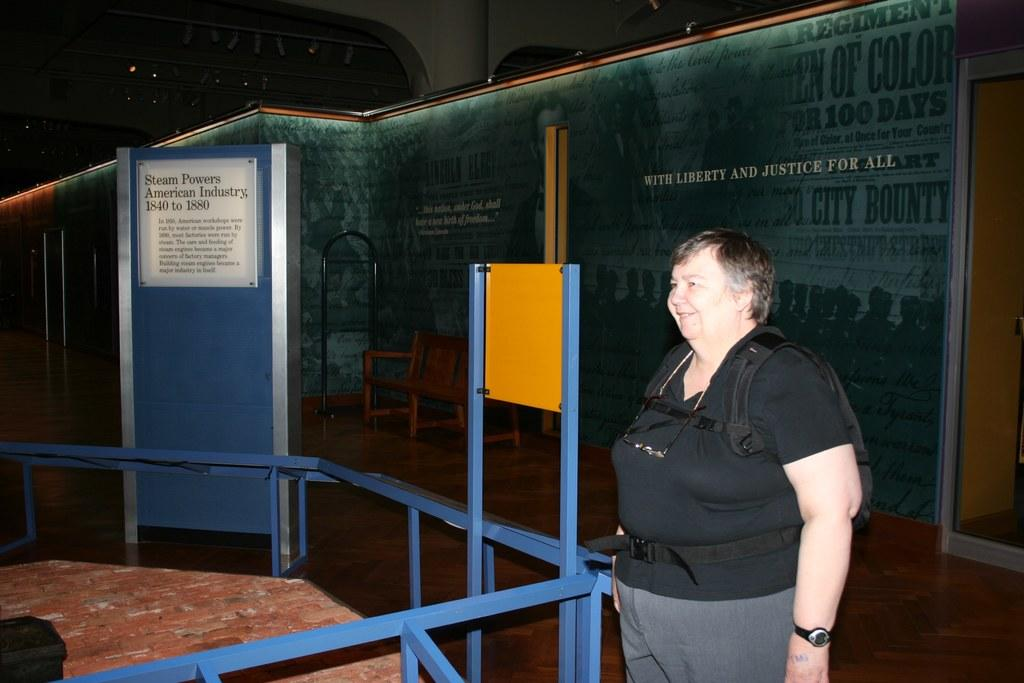What is the main subject of the image? There is a person standing in the image. What is the person standing on? The person is standing on a surface. What other objects can be seen in the image? There is a metal fence and a bench in the image. What type of cough is the person experiencing in the image? There is no indication of a cough or any health-related issue in the image. 